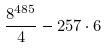<formula> <loc_0><loc_0><loc_500><loc_500>\frac { 8 ^ { 4 8 5 } } { 4 } - 2 5 7 \cdot 6</formula> 